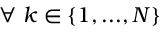Convert formula to latex. <formula><loc_0><loc_0><loc_500><loc_500>\forall \ k \in \{ 1 , \dots , N \}</formula> 